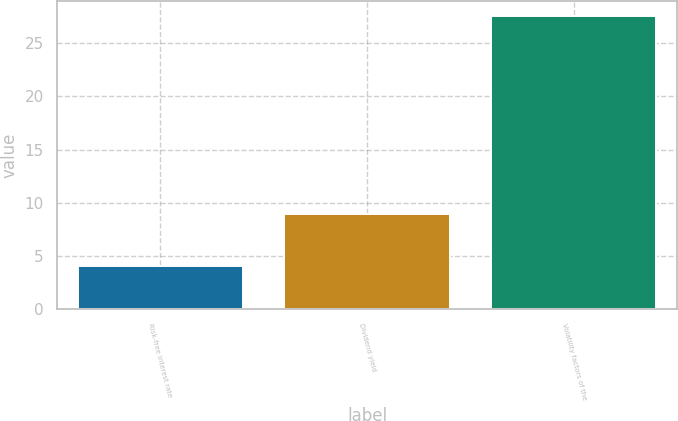Convert chart. <chart><loc_0><loc_0><loc_500><loc_500><bar_chart><fcel>Risk-free interest rate<fcel>Dividend yield<fcel>Volatility factors of the<nl><fcel>4.1<fcel>9<fcel>27.6<nl></chart> 